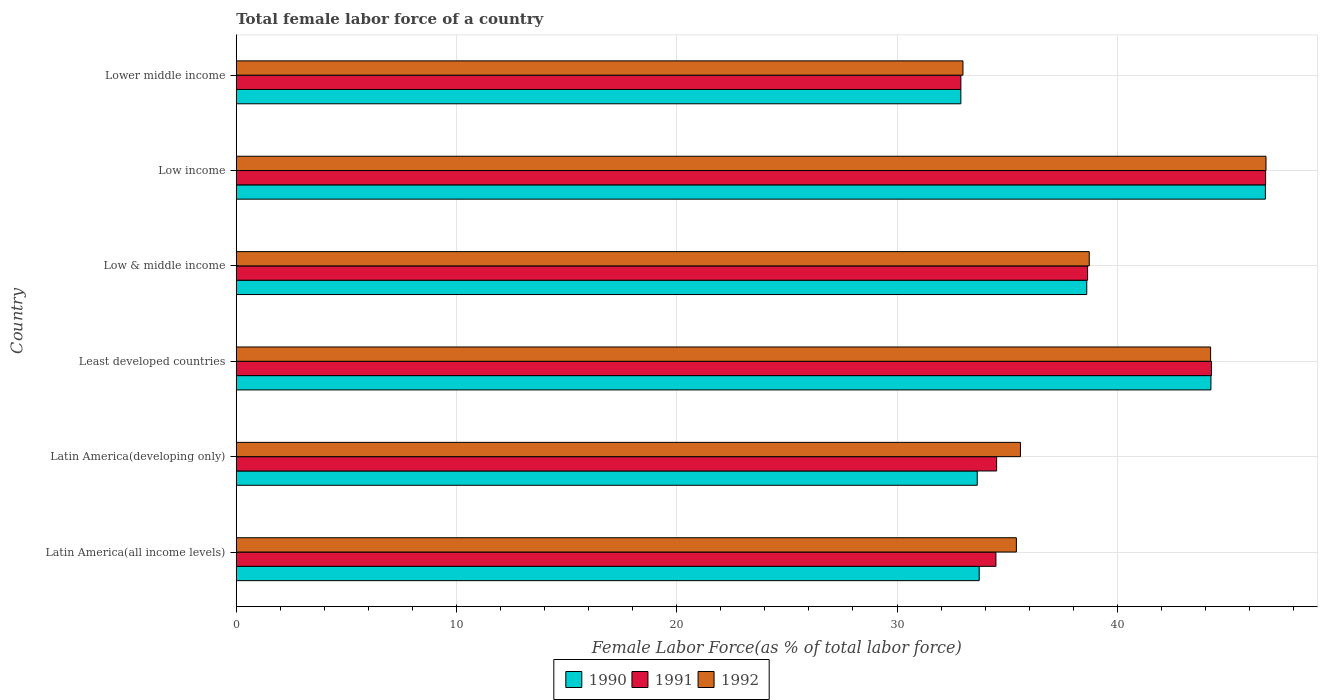How many different coloured bars are there?
Ensure brevity in your answer.  3. How many groups of bars are there?
Provide a succinct answer. 6. Are the number of bars on each tick of the Y-axis equal?
Give a very brief answer. Yes. How many bars are there on the 5th tick from the top?
Your answer should be very brief. 3. What is the label of the 2nd group of bars from the top?
Offer a terse response. Low income. In how many cases, is the number of bars for a given country not equal to the number of legend labels?
Make the answer very short. 0. What is the percentage of female labor force in 1992 in Low & middle income?
Provide a succinct answer. 38.73. Across all countries, what is the maximum percentage of female labor force in 1991?
Offer a very short reply. 46.74. Across all countries, what is the minimum percentage of female labor force in 1991?
Your response must be concise. 32.9. In which country was the percentage of female labor force in 1992 minimum?
Make the answer very short. Lower middle income. What is the total percentage of female labor force in 1991 in the graph?
Provide a short and direct response. 231.58. What is the difference between the percentage of female labor force in 1991 in Latin America(developing only) and that in Low & middle income?
Your answer should be very brief. -4.13. What is the difference between the percentage of female labor force in 1991 in Latin America(all income levels) and the percentage of female labor force in 1990 in Latin America(developing only)?
Ensure brevity in your answer.  0.85. What is the average percentage of female labor force in 1991 per country?
Your response must be concise. 38.6. What is the difference between the percentage of female labor force in 1992 and percentage of female labor force in 1991 in Low & middle income?
Offer a very short reply. 0.07. In how many countries, is the percentage of female labor force in 1990 greater than 42 %?
Your answer should be very brief. 2. What is the ratio of the percentage of female labor force in 1991 in Latin America(developing only) to that in Lower middle income?
Make the answer very short. 1.05. Is the difference between the percentage of female labor force in 1992 in Least developed countries and Lower middle income greater than the difference between the percentage of female labor force in 1991 in Least developed countries and Lower middle income?
Provide a succinct answer. No. What is the difference between the highest and the second highest percentage of female labor force in 1990?
Give a very brief answer. 2.47. What is the difference between the highest and the lowest percentage of female labor force in 1992?
Give a very brief answer. 13.76. Is the sum of the percentage of female labor force in 1992 in Least developed countries and Low income greater than the maximum percentage of female labor force in 1991 across all countries?
Give a very brief answer. Yes. What does the 1st bar from the top in Low income represents?
Your answer should be very brief. 1992. Is it the case that in every country, the sum of the percentage of female labor force in 1991 and percentage of female labor force in 1992 is greater than the percentage of female labor force in 1990?
Ensure brevity in your answer.  Yes. Are all the bars in the graph horizontal?
Provide a succinct answer. Yes. How many countries are there in the graph?
Offer a very short reply. 6. What is the difference between two consecutive major ticks on the X-axis?
Your response must be concise. 10. Does the graph contain grids?
Provide a succinct answer. Yes. How are the legend labels stacked?
Provide a succinct answer. Horizontal. What is the title of the graph?
Give a very brief answer. Total female labor force of a country. What is the label or title of the X-axis?
Make the answer very short. Female Labor Force(as % of total labor force). What is the label or title of the Y-axis?
Make the answer very short. Country. What is the Female Labor Force(as % of total labor force) of 1990 in Latin America(all income levels)?
Offer a terse response. 33.73. What is the Female Labor Force(as % of total labor force) of 1991 in Latin America(all income levels)?
Keep it short and to the point. 34.49. What is the Female Labor Force(as % of total labor force) in 1992 in Latin America(all income levels)?
Keep it short and to the point. 35.42. What is the Female Labor Force(as % of total labor force) in 1990 in Latin America(developing only)?
Give a very brief answer. 33.64. What is the Female Labor Force(as % of total labor force) of 1991 in Latin America(developing only)?
Give a very brief answer. 34.52. What is the Female Labor Force(as % of total labor force) in 1992 in Latin America(developing only)?
Your answer should be very brief. 35.6. What is the Female Labor Force(as % of total labor force) of 1990 in Least developed countries?
Make the answer very short. 44.25. What is the Female Labor Force(as % of total labor force) in 1991 in Least developed countries?
Offer a very short reply. 44.28. What is the Female Labor Force(as % of total labor force) in 1992 in Least developed countries?
Make the answer very short. 44.24. What is the Female Labor Force(as % of total labor force) in 1990 in Low & middle income?
Your answer should be very brief. 38.62. What is the Female Labor Force(as % of total labor force) in 1991 in Low & middle income?
Provide a short and direct response. 38.65. What is the Female Labor Force(as % of total labor force) in 1992 in Low & middle income?
Ensure brevity in your answer.  38.73. What is the Female Labor Force(as % of total labor force) in 1990 in Low income?
Provide a succinct answer. 46.73. What is the Female Labor Force(as % of total labor force) in 1991 in Low income?
Ensure brevity in your answer.  46.74. What is the Female Labor Force(as % of total labor force) in 1992 in Low income?
Your answer should be very brief. 46.75. What is the Female Labor Force(as % of total labor force) of 1990 in Lower middle income?
Your answer should be very brief. 32.9. What is the Female Labor Force(as % of total labor force) of 1991 in Lower middle income?
Provide a succinct answer. 32.9. What is the Female Labor Force(as % of total labor force) of 1992 in Lower middle income?
Offer a terse response. 32.99. Across all countries, what is the maximum Female Labor Force(as % of total labor force) of 1990?
Offer a terse response. 46.73. Across all countries, what is the maximum Female Labor Force(as % of total labor force) in 1991?
Your answer should be compact. 46.74. Across all countries, what is the maximum Female Labor Force(as % of total labor force) of 1992?
Make the answer very short. 46.75. Across all countries, what is the minimum Female Labor Force(as % of total labor force) in 1990?
Offer a terse response. 32.9. Across all countries, what is the minimum Female Labor Force(as % of total labor force) of 1991?
Keep it short and to the point. 32.9. Across all countries, what is the minimum Female Labor Force(as % of total labor force) in 1992?
Provide a succinct answer. 32.99. What is the total Female Labor Force(as % of total labor force) of 1990 in the graph?
Provide a succinct answer. 229.87. What is the total Female Labor Force(as % of total labor force) in 1991 in the graph?
Provide a succinct answer. 231.58. What is the total Female Labor Force(as % of total labor force) of 1992 in the graph?
Ensure brevity in your answer.  233.74. What is the difference between the Female Labor Force(as % of total labor force) in 1990 in Latin America(all income levels) and that in Latin America(developing only)?
Make the answer very short. 0.09. What is the difference between the Female Labor Force(as % of total labor force) of 1991 in Latin America(all income levels) and that in Latin America(developing only)?
Provide a succinct answer. -0.03. What is the difference between the Female Labor Force(as % of total labor force) of 1992 in Latin America(all income levels) and that in Latin America(developing only)?
Your answer should be compact. -0.18. What is the difference between the Female Labor Force(as % of total labor force) of 1990 in Latin America(all income levels) and that in Least developed countries?
Provide a short and direct response. -10.52. What is the difference between the Female Labor Force(as % of total labor force) in 1991 in Latin America(all income levels) and that in Least developed countries?
Provide a succinct answer. -9.79. What is the difference between the Female Labor Force(as % of total labor force) of 1992 in Latin America(all income levels) and that in Least developed countries?
Your response must be concise. -8.82. What is the difference between the Female Labor Force(as % of total labor force) in 1990 in Latin America(all income levels) and that in Low & middle income?
Provide a succinct answer. -4.88. What is the difference between the Female Labor Force(as % of total labor force) of 1991 in Latin America(all income levels) and that in Low & middle income?
Your response must be concise. -4.16. What is the difference between the Female Labor Force(as % of total labor force) of 1992 in Latin America(all income levels) and that in Low & middle income?
Make the answer very short. -3.31. What is the difference between the Female Labor Force(as % of total labor force) in 1990 in Latin America(all income levels) and that in Low income?
Offer a terse response. -12.99. What is the difference between the Female Labor Force(as % of total labor force) in 1991 in Latin America(all income levels) and that in Low income?
Ensure brevity in your answer.  -12.25. What is the difference between the Female Labor Force(as % of total labor force) of 1992 in Latin America(all income levels) and that in Low income?
Give a very brief answer. -11.33. What is the difference between the Female Labor Force(as % of total labor force) of 1990 in Latin America(all income levels) and that in Lower middle income?
Keep it short and to the point. 0.83. What is the difference between the Female Labor Force(as % of total labor force) of 1991 in Latin America(all income levels) and that in Lower middle income?
Offer a terse response. 1.59. What is the difference between the Female Labor Force(as % of total labor force) of 1992 in Latin America(all income levels) and that in Lower middle income?
Provide a short and direct response. 2.43. What is the difference between the Female Labor Force(as % of total labor force) in 1990 in Latin America(developing only) and that in Least developed countries?
Provide a succinct answer. -10.61. What is the difference between the Female Labor Force(as % of total labor force) of 1991 in Latin America(developing only) and that in Least developed countries?
Offer a very short reply. -9.75. What is the difference between the Female Labor Force(as % of total labor force) of 1992 in Latin America(developing only) and that in Least developed countries?
Your response must be concise. -8.63. What is the difference between the Female Labor Force(as % of total labor force) of 1990 in Latin America(developing only) and that in Low & middle income?
Provide a short and direct response. -4.97. What is the difference between the Female Labor Force(as % of total labor force) in 1991 in Latin America(developing only) and that in Low & middle income?
Keep it short and to the point. -4.13. What is the difference between the Female Labor Force(as % of total labor force) of 1992 in Latin America(developing only) and that in Low & middle income?
Give a very brief answer. -3.12. What is the difference between the Female Labor Force(as % of total labor force) in 1990 in Latin America(developing only) and that in Low income?
Provide a short and direct response. -13.08. What is the difference between the Female Labor Force(as % of total labor force) in 1991 in Latin America(developing only) and that in Low income?
Ensure brevity in your answer.  -12.21. What is the difference between the Female Labor Force(as % of total labor force) in 1992 in Latin America(developing only) and that in Low income?
Keep it short and to the point. -11.15. What is the difference between the Female Labor Force(as % of total labor force) of 1990 in Latin America(developing only) and that in Lower middle income?
Give a very brief answer. 0.74. What is the difference between the Female Labor Force(as % of total labor force) of 1991 in Latin America(developing only) and that in Lower middle income?
Give a very brief answer. 1.62. What is the difference between the Female Labor Force(as % of total labor force) of 1992 in Latin America(developing only) and that in Lower middle income?
Give a very brief answer. 2.61. What is the difference between the Female Labor Force(as % of total labor force) of 1990 in Least developed countries and that in Low & middle income?
Your answer should be very brief. 5.64. What is the difference between the Female Labor Force(as % of total labor force) of 1991 in Least developed countries and that in Low & middle income?
Your answer should be compact. 5.62. What is the difference between the Female Labor Force(as % of total labor force) in 1992 in Least developed countries and that in Low & middle income?
Provide a short and direct response. 5.51. What is the difference between the Female Labor Force(as % of total labor force) in 1990 in Least developed countries and that in Low income?
Offer a very short reply. -2.47. What is the difference between the Female Labor Force(as % of total labor force) of 1991 in Least developed countries and that in Low income?
Provide a short and direct response. -2.46. What is the difference between the Female Labor Force(as % of total labor force) of 1992 in Least developed countries and that in Low income?
Keep it short and to the point. -2.52. What is the difference between the Female Labor Force(as % of total labor force) of 1990 in Least developed countries and that in Lower middle income?
Make the answer very short. 11.35. What is the difference between the Female Labor Force(as % of total labor force) in 1991 in Least developed countries and that in Lower middle income?
Your answer should be very brief. 11.38. What is the difference between the Female Labor Force(as % of total labor force) of 1992 in Least developed countries and that in Lower middle income?
Give a very brief answer. 11.24. What is the difference between the Female Labor Force(as % of total labor force) of 1990 in Low & middle income and that in Low income?
Provide a short and direct response. -8.11. What is the difference between the Female Labor Force(as % of total labor force) in 1991 in Low & middle income and that in Low income?
Provide a short and direct response. -8.08. What is the difference between the Female Labor Force(as % of total labor force) of 1992 in Low & middle income and that in Low income?
Your response must be concise. -8.03. What is the difference between the Female Labor Force(as % of total labor force) of 1990 in Low & middle income and that in Lower middle income?
Provide a short and direct response. 5.72. What is the difference between the Female Labor Force(as % of total labor force) in 1991 in Low & middle income and that in Lower middle income?
Offer a terse response. 5.75. What is the difference between the Female Labor Force(as % of total labor force) in 1992 in Low & middle income and that in Lower middle income?
Your answer should be compact. 5.73. What is the difference between the Female Labor Force(as % of total labor force) of 1990 in Low income and that in Lower middle income?
Make the answer very short. 13.83. What is the difference between the Female Labor Force(as % of total labor force) of 1991 in Low income and that in Lower middle income?
Give a very brief answer. 13.84. What is the difference between the Female Labor Force(as % of total labor force) in 1992 in Low income and that in Lower middle income?
Provide a short and direct response. 13.76. What is the difference between the Female Labor Force(as % of total labor force) of 1990 in Latin America(all income levels) and the Female Labor Force(as % of total labor force) of 1991 in Latin America(developing only)?
Provide a succinct answer. -0.79. What is the difference between the Female Labor Force(as % of total labor force) of 1990 in Latin America(all income levels) and the Female Labor Force(as % of total labor force) of 1992 in Latin America(developing only)?
Make the answer very short. -1.87. What is the difference between the Female Labor Force(as % of total labor force) of 1991 in Latin America(all income levels) and the Female Labor Force(as % of total labor force) of 1992 in Latin America(developing only)?
Make the answer very short. -1.11. What is the difference between the Female Labor Force(as % of total labor force) of 1990 in Latin America(all income levels) and the Female Labor Force(as % of total labor force) of 1991 in Least developed countries?
Provide a short and direct response. -10.55. What is the difference between the Female Labor Force(as % of total labor force) of 1990 in Latin America(all income levels) and the Female Labor Force(as % of total labor force) of 1992 in Least developed countries?
Offer a terse response. -10.51. What is the difference between the Female Labor Force(as % of total labor force) in 1991 in Latin America(all income levels) and the Female Labor Force(as % of total labor force) in 1992 in Least developed countries?
Make the answer very short. -9.75. What is the difference between the Female Labor Force(as % of total labor force) of 1990 in Latin America(all income levels) and the Female Labor Force(as % of total labor force) of 1991 in Low & middle income?
Your answer should be very brief. -4.92. What is the difference between the Female Labor Force(as % of total labor force) of 1990 in Latin America(all income levels) and the Female Labor Force(as % of total labor force) of 1992 in Low & middle income?
Offer a terse response. -5. What is the difference between the Female Labor Force(as % of total labor force) of 1991 in Latin America(all income levels) and the Female Labor Force(as % of total labor force) of 1992 in Low & middle income?
Make the answer very short. -4.24. What is the difference between the Female Labor Force(as % of total labor force) in 1990 in Latin America(all income levels) and the Female Labor Force(as % of total labor force) in 1991 in Low income?
Give a very brief answer. -13. What is the difference between the Female Labor Force(as % of total labor force) of 1990 in Latin America(all income levels) and the Female Labor Force(as % of total labor force) of 1992 in Low income?
Make the answer very short. -13.02. What is the difference between the Female Labor Force(as % of total labor force) in 1991 in Latin America(all income levels) and the Female Labor Force(as % of total labor force) in 1992 in Low income?
Offer a very short reply. -12.26. What is the difference between the Female Labor Force(as % of total labor force) of 1990 in Latin America(all income levels) and the Female Labor Force(as % of total labor force) of 1991 in Lower middle income?
Provide a short and direct response. 0.83. What is the difference between the Female Labor Force(as % of total labor force) of 1990 in Latin America(all income levels) and the Female Labor Force(as % of total labor force) of 1992 in Lower middle income?
Provide a succinct answer. 0.74. What is the difference between the Female Labor Force(as % of total labor force) in 1991 in Latin America(all income levels) and the Female Labor Force(as % of total labor force) in 1992 in Lower middle income?
Offer a terse response. 1.5. What is the difference between the Female Labor Force(as % of total labor force) in 1990 in Latin America(developing only) and the Female Labor Force(as % of total labor force) in 1991 in Least developed countries?
Keep it short and to the point. -10.63. What is the difference between the Female Labor Force(as % of total labor force) in 1990 in Latin America(developing only) and the Female Labor Force(as % of total labor force) in 1992 in Least developed countries?
Make the answer very short. -10.6. What is the difference between the Female Labor Force(as % of total labor force) in 1991 in Latin America(developing only) and the Female Labor Force(as % of total labor force) in 1992 in Least developed countries?
Keep it short and to the point. -9.72. What is the difference between the Female Labor Force(as % of total labor force) in 1990 in Latin America(developing only) and the Female Labor Force(as % of total labor force) in 1991 in Low & middle income?
Offer a terse response. -5.01. What is the difference between the Female Labor Force(as % of total labor force) of 1990 in Latin America(developing only) and the Female Labor Force(as % of total labor force) of 1992 in Low & middle income?
Ensure brevity in your answer.  -5.09. What is the difference between the Female Labor Force(as % of total labor force) in 1991 in Latin America(developing only) and the Female Labor Force(as % of total labor force) in 1992 in Low & middle income?
Provide a short and direct response. -4.21. What is the difference between the Female Labor Force(as % of total labor force) of 1990 in Latin America(developing only) and the Female Labor Force(as % of total labor force) of 1991 in Low income?
Provide a short and direct response. -13.09. What is the difference between the Female Labor Force(as % of total labor force) of 1990 in Latin America(developing only) and the Female Labor Force(as % of total labor force) of 1992 in Low income?
Your answer should be compact. -13.11. What is the difference between the Female Labor Force(as % of total labor force) in 1991 in Latin America(developing only) and the Female Labor Force(as % of total labor force) in 1992 in Low income?
Provide a succinct answer. -12.23. What is the difference between the Female Labor Force(as % of total labor force) in 1990 in Latin America(developing only) and the Female Labor Force(as % of total labor force) in 1991 in Lower middle income?
Your answer should be compact. 0.74. What is the difference between the Female Labor Force(as % of total labor force) of 1990 in Latin America(developing only) and the Female Labor Force(as % of total labor force) of 1992 in Lower middle income?
Make the answer very short. 0.65. What is the difference between the Female Labor Force(as % of total labor force) of 1991 in Latin America(developing only) and the Female Labor Force(as % of total labor force) of 1992 in Lower middle income?
Keep it short and to the point. 1.53. What is the difference between the Female Labor Force(as % of total labor force) of 1990 in Least developed countries and the Female Labor Force(as % of total labor force) of 1991 in Low & middle income?
Provide a succinct answer. 5.6. What is the difference between the Female Labor Force(as % of total labor force) of 1990 in Least developed countries and the Female Labor Force(as % of total labor force) of 1992 in Low & middle income?
Offer a terse response. 5.53. What is the difference between the Female Labor Force(as % of total labor force) in 1991 in Least developed countries and the Female Labor Force(as % of total labor force) in 1992 in Low & middle income?
Provide a short and direct response. 5.55. What is the difference between the Female Labor Force(as % of total labor force) of 1990 in Least developed countries and the Female Labor Force(as % of total labor force) of 1991 in Low income?
Your answer should be very brief. -2.48. What is the difference between the Female Labor Force(as % of total labor force) in 1990 in Least developed countries and the Female Labor Force(as % of total labor force) in 1992 in Low income?
Ensure brevity in your answer.  -2.5. What is the difference between the Female Labor Force(as % of total labor force) in 1991 in Least developed countries and the Female Labor Force(as % of total labor force) in 1992 in Low income?
Your response must be concise. -2.48. What is the difference between the Female Labor Force(as % of total labor force) of 1990 in Least developed countries and the Female Labor Force(as % of total labor force) of 1991 in Lower middle income?
Your answer should be very brief. 11.35. What is the difference between the Female Labor Force(as % of total labor force) in 1990 in Least developed countries and the Female Labor Force(as % of total labor force) in 1992 in Lower middle income?
Make the answer very short. 11.26. What is the difference between the Female Labor Force(as % of total labor force) of 1991 in Least developed countries and the Female Labor Force(as % of total labor force) of 1992 in Lower middle income?
Offer a very short reply. 11.28. What is the difference between the Female Labor Force(as % of total labor force) of 1990 in Low & middle income and the Female Labor Force(as % of total labor force) of 1991 in Low income?
Your response must be concise. -8.12. What is the difference between the Female Labor Force(as % of total labor force) in 1990 in Low & middle income and the Female Labor Force(as % of total labor force) in 1992 in Low income?
Offer a terse response. -8.14. What is the difference between the Female Labor Force(as % of total labor force) of 1991 in Low & middle income and the Female Labor Force(as % of total labor force) of 1992 in Low income?
Your answer should be compact. -8.1. What is the difference between the Female Labor Force(as % of total labor force) of 1990 in Low & middle income and the Female Labor Force(as % of total labor force) of 1991 in Lower middle income?
Make the answer very short. 5.72. What is the difference between the Female Labor Force(as % of total labor force) of 1990 in Low & middle income and the Female Labor Force(as % of total labor force) of 1992 in Lower middle income?
Give a very brief answer. 5.62. What is the difference between the Female Labor Force(as % of total labor force) of 1991 in Low & middle income and the Female Labor Force(as % of total labor force) of 1992 in Lower middle income?
Your response must be concise. 5.66. What is the difference between the Female Labor Force(as % of total labor force) in 1990 in Low income and the Female Labor Force(as % of total labor force) in 1991 in Lower middle income?
Offer a very short reply. 13.83. What is the difference between the Female Labor Force(as % of total labor force) of 1990 in Low income and the Female Labor Force(as % of total labor force) of 1992 in Lower middle income?
Make the answer very short. 13.73. What is the difference between the Female Labor Force(as % of total labor force) in 1991 in Low income and the Female Labor Force(as % of total labor force) in 1992 in Lower middle income?
Keep it short and to the point. 13.74. What is the average Female Labor Force(as % of total labor force) of 1990 per country?
Your answer should be compact. 38.31. What is the average Female Labor Force(as % of total labor force) of 1991 per country?
Make the answer very short. 38.6. What is the average Female Labor Force(as % of total labor force) of 1992 per country?
Make the answer very short. 38.96. What is the difference between the Female Labor Force(as % of total labor force) of 1990 and Female Labor Force(as % of total labor force) of 1991 in Latin America(all income levels)?
Offer a very short reply. -0.76. What is the difference between the Female Labor Force(as % of total labor force) of 1990 and Female Labor Force(as % of total labor force) of 1992 in Latin America(all income levels)?
Provide a succinct answer. -1.69. What is the difference between the Female Labor Force(as % of total labor force) of 1991 and Female Labor Force(as % of total labor force) of 1992 in Latin America(all income levels)?
Provide a short and direct response. -0.93. What is the difference between the Female Labor Force(as % of total labor force) in 1990 and Female Labor Force(as % of total labor force) in 1991 in Latin America(developing only)?
Give a very brief answer. -0.88. What is the difference between the Female Labor Force(as % of total labor force) in 1990 and Female Labor Force(as % of total labor force) in 1992 in Latin America(developing only)?
Your answer should be very brief. -1.96. What is the difference between the Female Labor Force(as % of total labor force) in 1991 and Female Labor Force(as % of total labor force) in 1992 in Latin America(developing only)?
Your answer should be compact. -1.08. What is the difference between the Female Labor Force(as % of total labor force) in 1990 and Female Labor Force(as % of total labor force) in 1991 in Least developed countries?
Make the answer very short. -0.02. What is the difference between the Female Labor Force(as % of total labor force) of 1990 and Female Labor Force(as % of total labor force) of 1992 in Least developed countries?
Your response must be concise. 0.01. What is the difference between the Female Labor Force(as % of total labor force) in 1991 and Female Labor Force(as % of total labor force) in 1992 in Least developed countries?
Make the answer very short. 0.04. What is the difference between the Female Labor Force(as % of total labor force) of 1990 and Female Labor Force(as % of total labor force) of 1991 in Low & middle income?
Provide a succinct answer. -0.04. What is the difference between the Female Labor Force(as % of total labor force) in 1990 and Female Labor Force(as % of total labor force) in 1992 in Low & middle income?
Your response must be concise. -0.11. What is the difference between the Female Labor Force(as % of total labor force) of 1991 and Female Labor Force(as % of total labor force) of 1992 in Low & middle income?
Provide a short and direct response. -0.07. What is the difference between the Female Labor Force(as % of total labor force) in 1990 and Female Labor Force(as % of total labor force) in 1991 in Low income?
Keep it short and to the point. -0.01. What is the difference between the Female Labor Force(as % of total labor force) in 1990 and Female Labor Force(as % of total labor force) in 1992 in Low income?
Keep it short and to the point. -0.03. What is the difference between the Female Labor Force(as % of total labor force) of 1991 and Female Labor Force(as % of total labor force) of 1992 in Low income?
Provide a succinct answer. -0.02. What is the difference between the Female Labor Force(as % of total labor force) in 1990 and Female Labor Force(as % of total labor force) in 1991 in Lower middle income?
Ensure brevity in your answer.  -0. What is the difference between the Female Labor Force(as % of total labor force) in 1990 and Female Labor Force(as % of total labor force) in 1992 in Lower middle income?
Offer a terse response. -0.09. What is the difference between the Female Labor Force(as % of total labor force) in 1991 and Female Labor Force(as % of total labor force) in 1992 in Lower middle income?
Provide a short and direct response. -0.09. What is the ratio of the Female Labor Force(as % of total labor force) in 1990 in Latin America(all income levels) to that in Latin America(developing only)?
Your answer should be very brief. 1. What is the ratio of the Female Labor Force(as % of total labor force) of 1990 in Latin America(all income levels) to that in Least developed countries?
Make the answer very short. 0.76. What is the ratio of the Female Labor Force(as % of total labor force) in 1991 in Latin America(all income levels) to that in Least developed countries?
Keep it short and to the point. 0.78. What is the ratio of the Female Labor Force(as % of total labor force) of 1992 in Latin America(all income levels) to that in Least developed countries?
Provide a succinct answer. 0.8. What is the ratio of the Female Labor Force(as % of total labor force) in 1990 in Latin America(all income levels) to that in Low & middle income?
Your response must be concise. 0.87. What is the ratio of the Female Labor Force(as % of total labor force) in 1991 in Latin America(all income levels) to that in Low & middle income?
Keep it short and to the point. 0.89. What is the ratio of the Female Labor Force(as % of total labor force) of 1992 in Latin America(all income levels) to that in Low & middle income?
Make the answer very short. 0.91. What is the ratio of the Female Labor Force(as % of total labor force) in 1990 in Latin America(all income levels) to that in Low income?
Make the answer very short. 0.72. What is the ratio of the Female Labor Force(as % of total labor force) in 1991 in Latin America(all income levels) to that in Low income?
Offer a terse response. 0.74. What is the ratio of the Female Labor Force(as % of total labor force) in 1992 in Latin America(all income levels) to that in Low income?
Give a very brief answer. 0.76. What is the ratio of the Female Labor Force(as % of total labor force) in 1990 in Latin America(all income levels) to that in Lower middle income?
Make the answer very short. 1.03. What is the ratio of the Female Labor Force(as % of total labor force) of 1991 in Latin America(all income levels) to that in Lower middle income?
Offer a very short reply. 1.05. What is the ratio of the Female Labor Force(as % of total labor force) in 1992 in Latin America(all income levels) to that in Lower middle income?
Make the answer very short. 1.07. What is the ratio of the Female Labor Force(as % of total labor force) in 1990 in Latin America(developing only) to that in Least developed countries?
Offer a terse response. 0.76. What is the ratio of the Female Labor Force(as % of total labor force) of 1991 in Latin America(developing only) to that in Least developed countries?
Offer a terse response. 0.78. What is the ratio of the Female Labor Force(as % of total labor force) in 1992 in Latin America(developing only) to that in Least developed countries?
Ensure brevity in your answer.  0.8. What is the ratio of the Female Labor Force(as % of total labor force) in 1990 in Latin America(developing only) to that in Low & middle income?
Offer a terse response. 0.87. What is the ratio of the Female Labor Force(as % of total labor force) of 1991 in Latin America(developing only) to that in Low & middle income?
Offer a very short reply. 0.89. What is the ratio of the Female Labor Force(as % of total labor force) of 1992 in Latin America(developing only) to that in Low & middle income?
Your answer should be very brief. 0.92. What is the ratio of the Female Labor Force(as % of total labor force) of 1990 in Latin America(developing only) to that in Low income?
Your answer should be compact. 0.72. What is the ratio of the Female Labor Force(as % of total labor force) in 1991 in Latin America(developing only) to that in Low income?
Give a very brief answer. 0.74. What is the ratio of the Female Labor Force(as % of total labor force) of 1992 in Latin America(developing only) to that in Low income?
Provide a short and direct response. 0.76. What is the ratio of the Female Labor Force(as % of total labor force) of 1990 in Latin America(developing only) to that in Lower middle income?
Keep it short and to the point. 1.02. What is the ratio of the Female Labor Force(as % of total labor force) of 1991 in Latin America(developing only) to that in Lower middle income?
Ensure brevity in your answer.  1.05. What is the ratio of the Female Labor Force(as % of total labor force) in 1992 in Latin America(developing only) to that in Lower middle income?
Provide a succinct answer. 1.08. What is the ratio of the Female Labor Force(as % of total labor force) of 1990 in Least developed countries to that in Low & middle income?
Your answer should be very brief. 1.15. What is the ratio of the Female Labor Force(as % of total labor force) in 1991 in Least developed countries to that in Low & middle income?
Offer a terse response. 1.15. What is the ratio of the Female Labor Force(as % of total labor force) of 1992 in Least developed countries to that in Low & middle income?
Your response must be concise. 1.14. What is the ratio of the Female Labor Force(as % of total labor force) in 1990 in Least developed countries to that in Low income?
Your answer should be compact. 0.95. What is the ratio of the Female Labor Force(as % of total labor force) in 1992 in Least developed countries to that in Low income?
Your answer should be compact. 0.95. What is the ratio of the Female Labor Force(as % of total labor force) of 1990 in Least developed countries to that in Lower middle income?
Your response must be concise. 1.35. What is the ratio of the Female Labor Force(as % of total labor force) in 1991 in Least developed countries to that in Lower middle income?
Your response must be concise. 1.35. What is the ratio of the Female Labor Force(as % of total labor force) of 1992 in Least developed countries to that in Lower middle income?
Make the answer very short. 1.34. What is the ratio of the Female Labor Force(as % of total labor force) in 1990 in Low & middle income to that in Low income?
Offer a very short reply. 0.83. What is the ratio of the Female Labor Force(as % of total labor force) of 1991 in Low & middle income to that in Low income?
Give a very brief answer. 0.83. What is the ratio of the Female Labor Force(as % of total labor force) of 1992 in Low & middle income to that in Low income?
Offer a terse response. 0.83. What is the ratio of the Female Labor Force(as % of total labor force) in 1990 in Low & middle income to that in Lower middle income?
Keep it short and to the point. 1.17. What is the ratio of the Female Labor Force(as % of total labor force) in 1991 in Low & middle income to that in Lower middle income?
Offer a terse response. 1.17. What is the ratio of the Female Labor Force(as % of total labor force) in 1992 in Low & middle income to that in Lower middle income?
Provide a succinct answer. 1.17. What is the ratio of the Female Labor Force(as % of total labor force) in 1990 in Low income to that in Lower middle income?
Offer a terse response. 1.42. What is the ratio of the Female Labor Force(as % of total labor force) in 1991 in Low income to that in Lower middle income?
Offer a terse response. 1.42. What is the ratio of the Female Labor Force(as % of total labor force) in 1992 in Low income to that in Lower middle income?
Make the answer very short. 1.42. What is the difference between the highest and the second highest Female Labor Force(as % of total labor force) of 1990?
Make the answer very short. 2.47. What is the difference between the highest and the second highest Female Labor Force(as % of total labor force) of 1991?
Your response must be concise. 2.46. What is the difference between the highest and the second highest Female Labor Force(as % of total labor force) in 1992?
Keep it short and to the point. 2.52. What is the difference between the highest and the lowest Female Labor Force(as % of total labor force) of 1990?
Ensure brevity in your answer.  13.83. What is the difference between the highest and the lowest Female Labor Force(as % of total labor force) in 1991?
Offer a terse response. 13.84. What is the difference between the highest and the lowest Female Labor Force(as % of total labor force) in 1992?
Give a very brief answer. 13.76. 